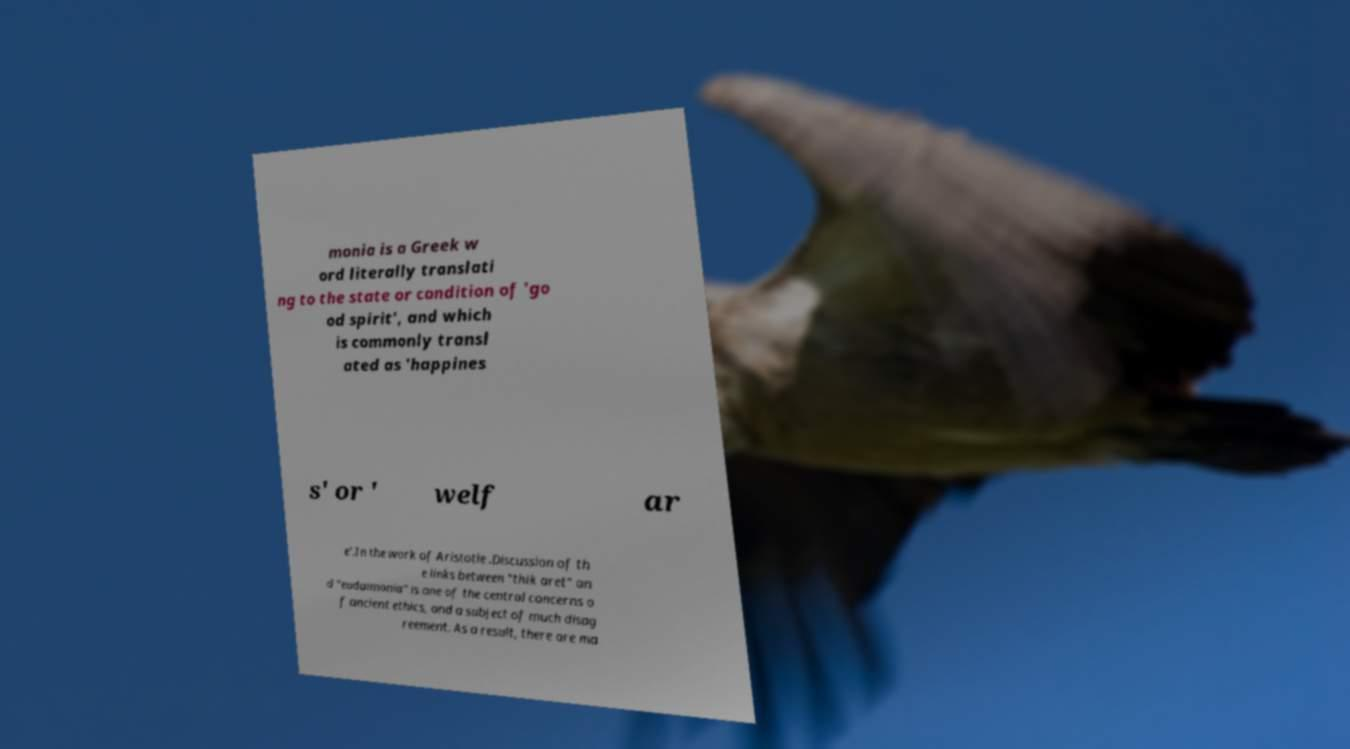Can you read and provide the text displayed in the image?This photo seems to have some interesting text. Can you extract and type it out for me? monia is a Greek w ord literally translati ng to the state or condition of 'go od spirit', and which is commonly transl ated as 'happines s' or ' welf ar e'.In the work of Aristotle .Discussion of th e links between "thik aret" an d "eudaimonia" is one of the central concerns o f ancient ethics, and a subject of much disag reement. As a result, there are ma 